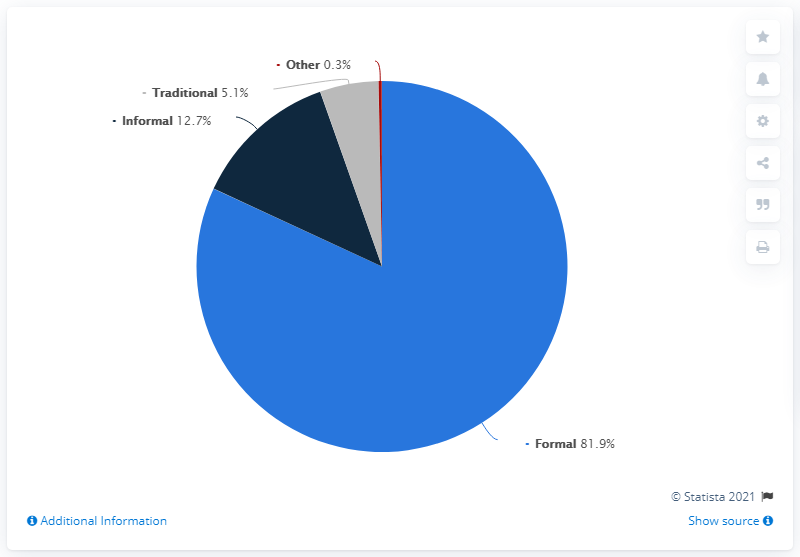Identify some key points in this picture. In South Africa, nearly 13% of the population still resides in informal dwellings. There are a total of 4 segments. The sum of the largest and second largest portions is 94.6. 